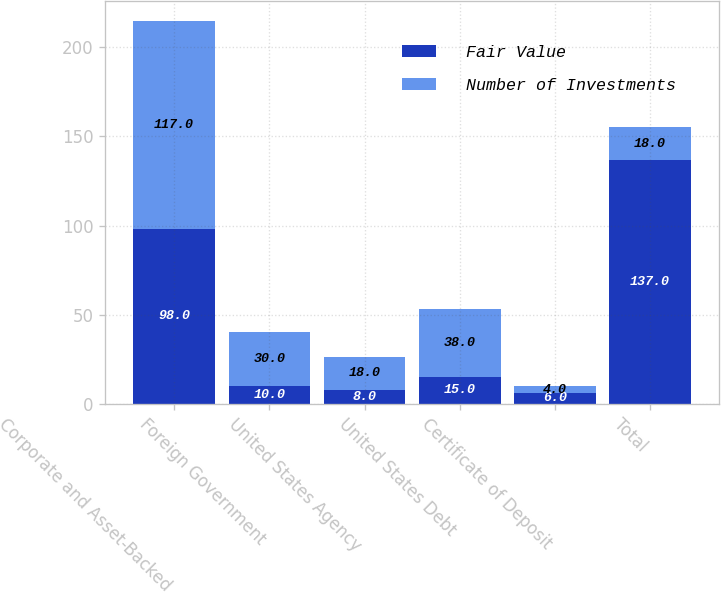Convert chart. <chart><loc_0><loc_0><loc_500><loc_500><stacked_bar_chart><ecel><fcel>Corporate and Asset-Backed<fcel>Foreign Government<fcel>United States Agency<fcel>United States Debt<fcel>Certificate of Deposit<fcel>Total<nl><fcel>Fair Value<fcel>98<fcel>10<fcel>8<fcel>15<fcel>6<fcel>137<nl><fcel>Number of Investments<fcel>117<fcel>30<fcel>18<fcel>38<fcel>4<fcel>18<nl></chart> 